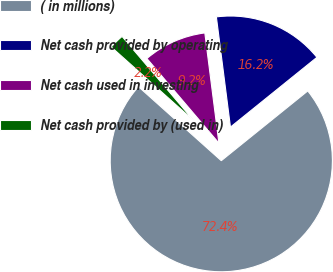<chart> <loc_0><loc_0><loc_500><loc_500><pie_chart><fcel>( in millions)<fcel>Net cash provided by operating<fcel>Net cash used in investing<fcel>Net cash provided by (used in)<nl><fcel>72.41%<fcel>16.22%<fcel>9.2%<fcel>2.17%<nl></chart> 